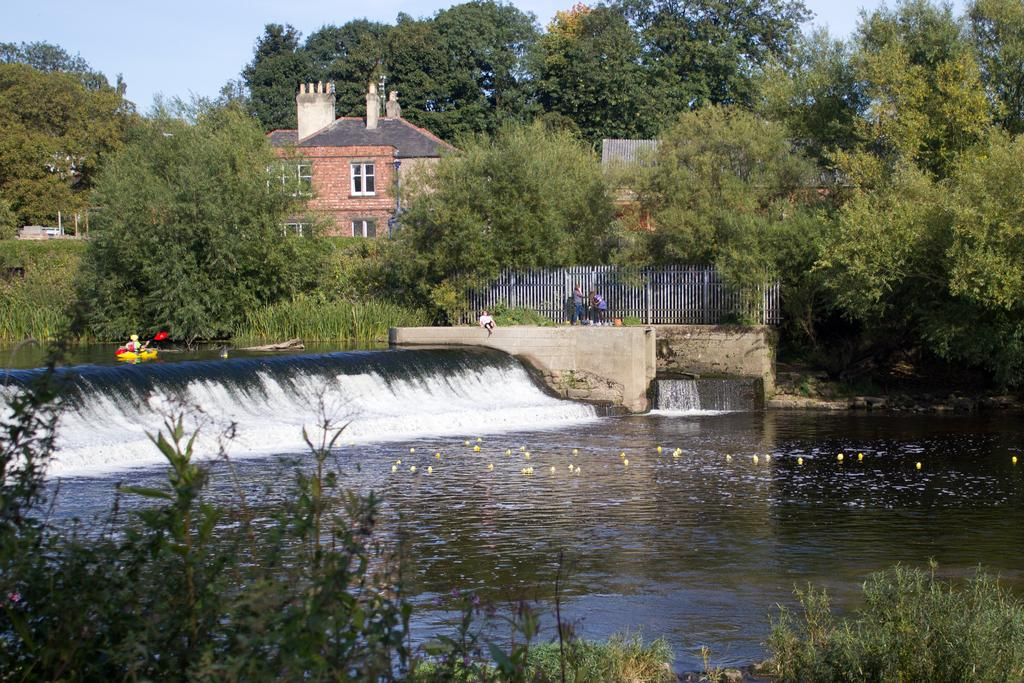What is present in the image that is not solid? There is water visible in the image. Who or what can be seen in the image? There are people in the image. What can be seen in the distance in the image? There are trees, a house, and the sky visible in the background of the image. What news is being discussed at the meeting in the image? There is no meeting or discussion of news present in the image. What answer is being provided by the person in the image? There is no person providing an answer in the image. 